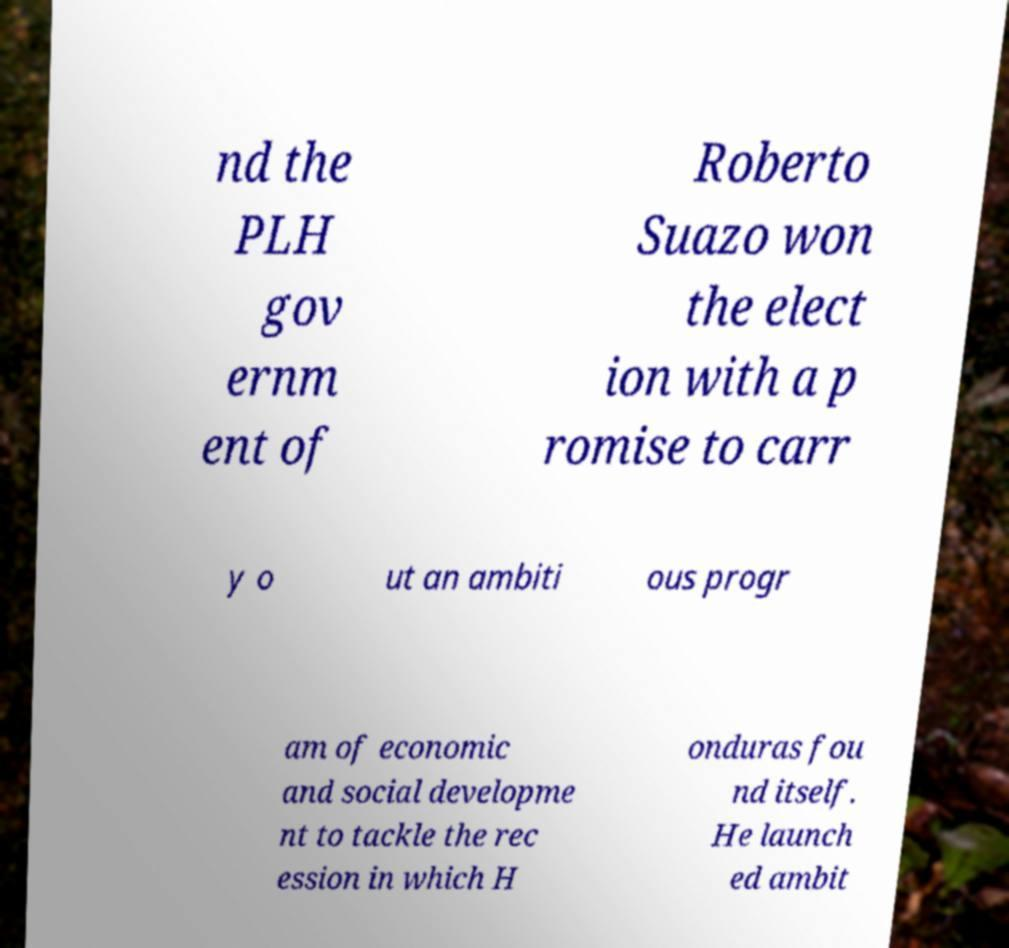I need the written content from this picture converted into text. Can you do that? nd the PLH gov ernm ent of Roberto Suazo won the elect ion with a p romise to carr y o ut an ambiti ous progr am of economic and social developme nt to tackle the rec ession in which H onduras fou nd itself. He launch ed ambit 